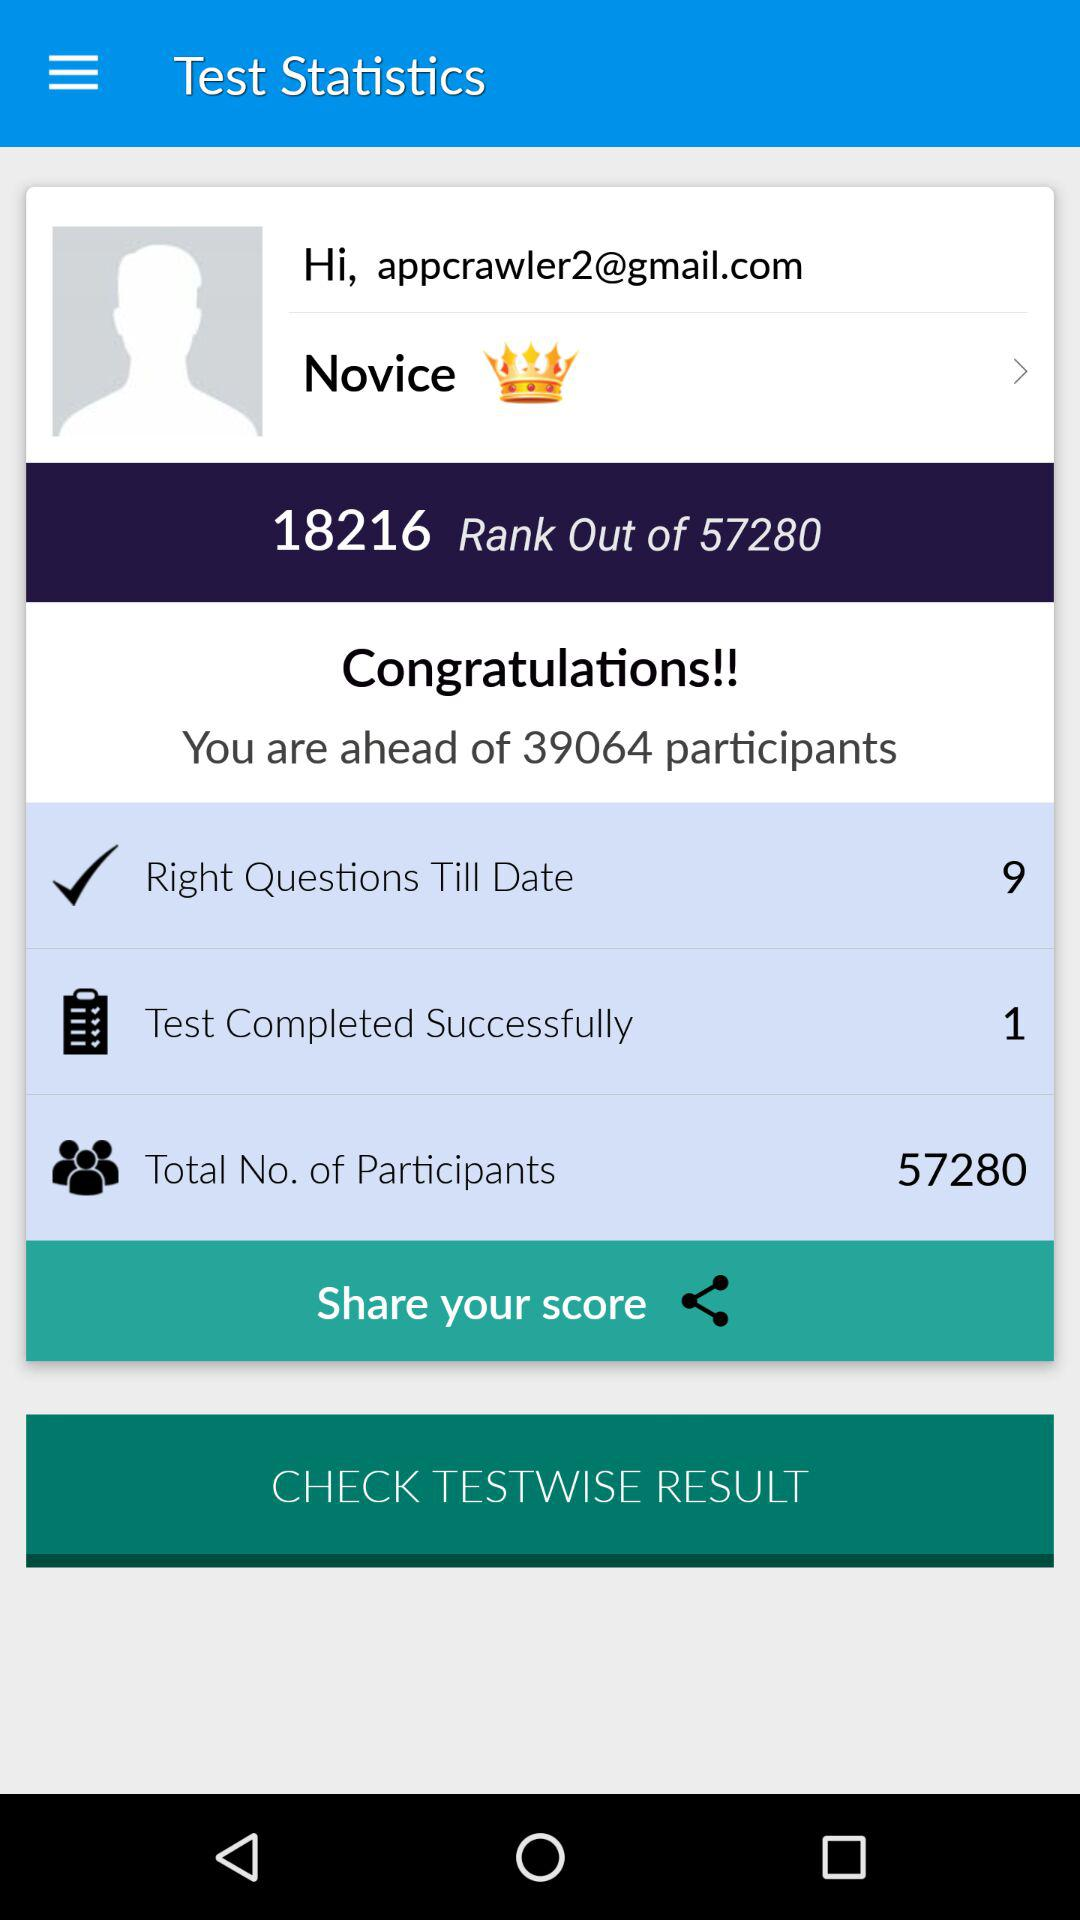How many tests were completed successfully? There was 1 test completed successfully. 